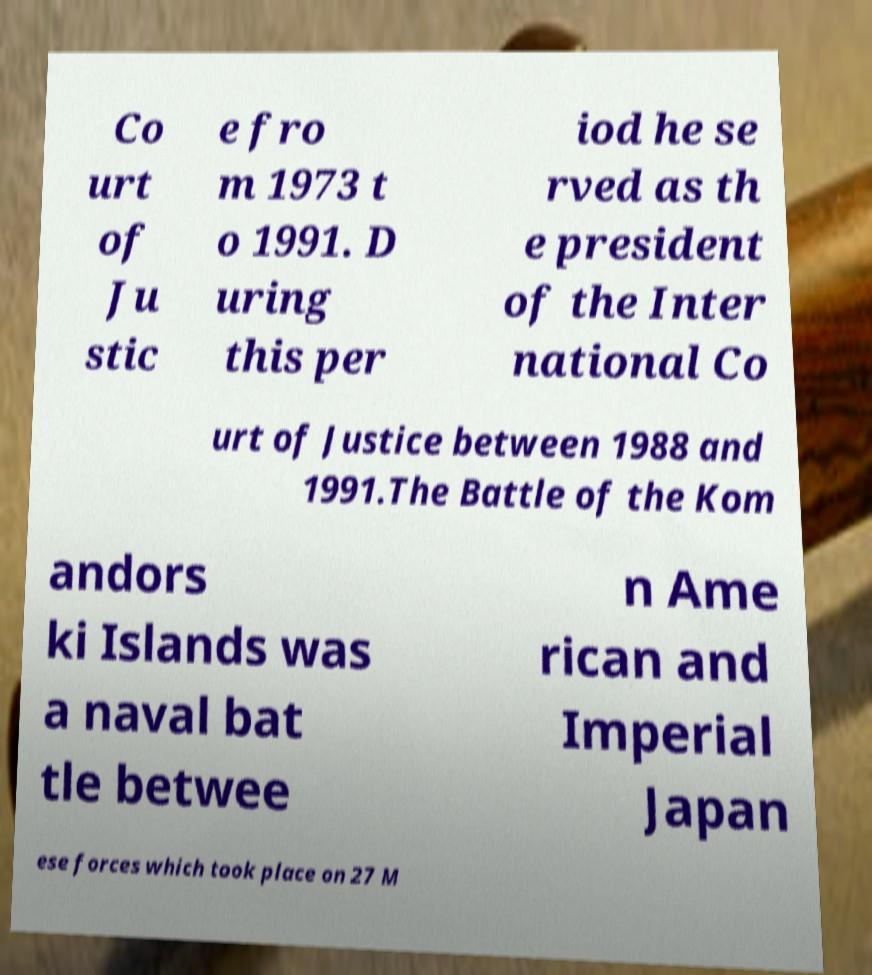There's text embedded in this image that I need extracted. Can you transcribe it verbatim? Co urt of Ju stic e fro m 1973 t o 1991. D uring this per iod he se rved as th e president of the Inter national Co urt of Justice between 1988 and 1991.The Battle of the Kom andors ki Islands was a naval bat tle betwee n Ame rican and Imperial Japan ese forces which took place on 27 M 